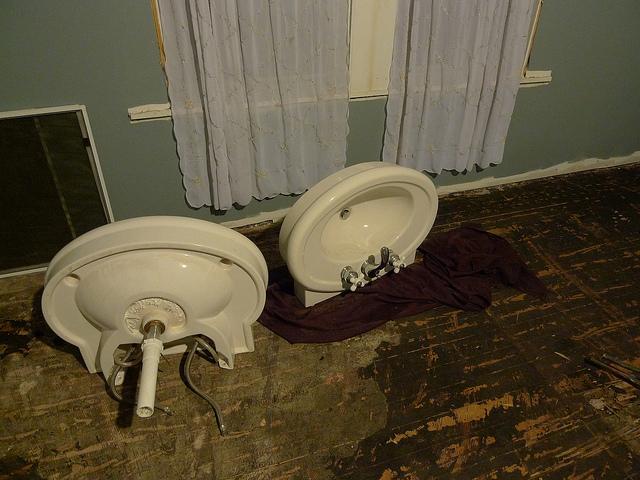What color are the curtains?
Answer briefly. White. What room are these for?
Keep it brief. Bathroom. What condition are the floors?
Give a very brief answer. Bad. 